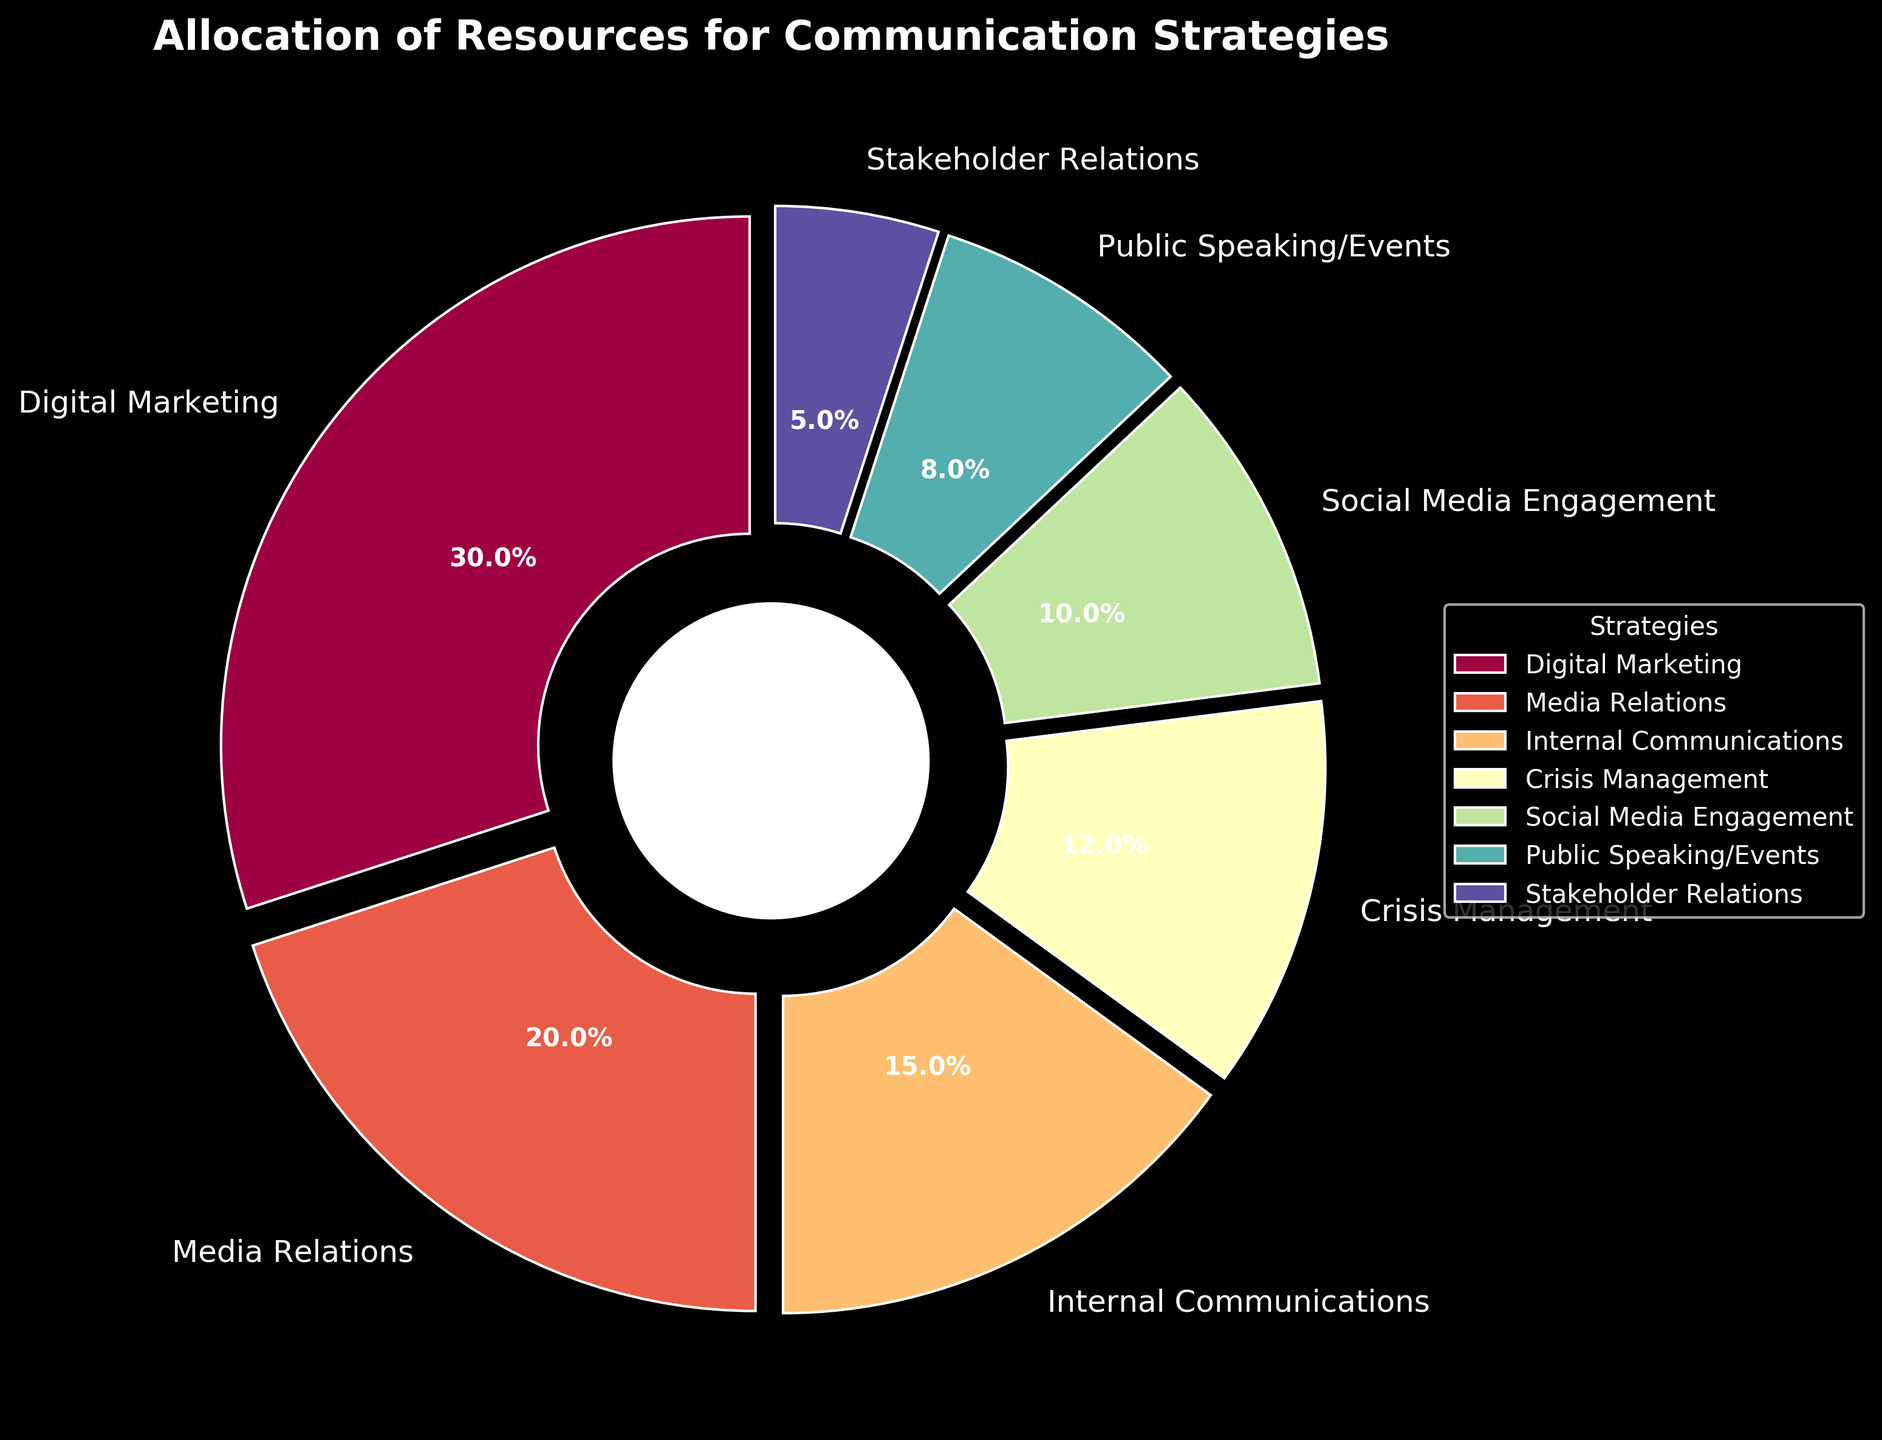Which strategy receives the highest allocation of resources? The largest segment in the pie chart, representing 30%, is allocated to Digital Marketing. Therefore, Digital Marketing receives the highest allocation of resources.
Answer: Digital Marketing What is the combined percentage for Internal Communications and Crisis Management? Internal Communications has 15% and Crisis Management has 12%. Adding these together gives 15% + 12% = 27%.
Answer: 27% Which strategy has a larger allocation: Media Relations or Social Media Engagement? Media Relations is allocated 20%, and Social Media Engagement is allocated 10%, making Media Relations the larger allocation.
Answer: Media Relations How does the allocation for Public Speaking/Events compare to Stakeholder Relations? Public Speaking/Events has an 8% allocation, while Stakeholder Relations has a 5% allocation. Therefore, Public Speaking/Events has a larger allocation.
Answer: Public Speaking/Events If the allocations for Digital Marketing and Media Relations were combined, what percentage of the total resources would they represent? Digital Marketing has 30% and Media Relations has 20%. Adding these together gives 30% + 20% = 50%.
Answer: 50% Which two strategies combined make up exactly one-quarter of the total allocation? Social Media Engagement is 10% and Public Speaking/Events is 8%. Adding Crisis Management’s 12% to Social Media Engagement’s 10% gives 22%, which is closest without going above a quarter of the total (25%). You have to instead combine Public Speaking/Events (8%) and Stakeholder Relations (5%) to achieve the next below quarter allocation 13%.
Answer: None makes exactly one-quarter What color represents Crisis Management in the figure? The specific wedge color schemes were determined using the 'Spectral' palette, and each wedge has a unique color. The precise hue for Crisis Management can be determined by checking the corresponding sector labeled 'Crisis Management' in the figure.
Answer: [Specific color from the figure] By how much does the allocation for Digital Marketing exceed that of Internal Communications? Digital Marketing is allocated 30%, while Internal Communications is allocated 15%. Therefore, Digital Marketing exceeds Internal Communications by 30% - 15% = 15%.
Answer: 15% What strategies together constitute the majority (more than 50%) of the resource allocation? Digital Marketing (30%) and Media Relations (20%) together constitute a combined total of 50%. To exceed 50%, adding any additional strategy (such as Internal Communications with 15%) will make it above 50%. Including the third will give 65%.
Answer: Digital Marketing, Media Relations, Internal Communications What is the difference in allocation between the smallest and the largest strategy? The smallest allocation is Stakeholder Relations at 5%, and the largest allocation is Digital Marketing at 30%. The difference between them is 30% - 5% = 25%.
Answer: 25% 